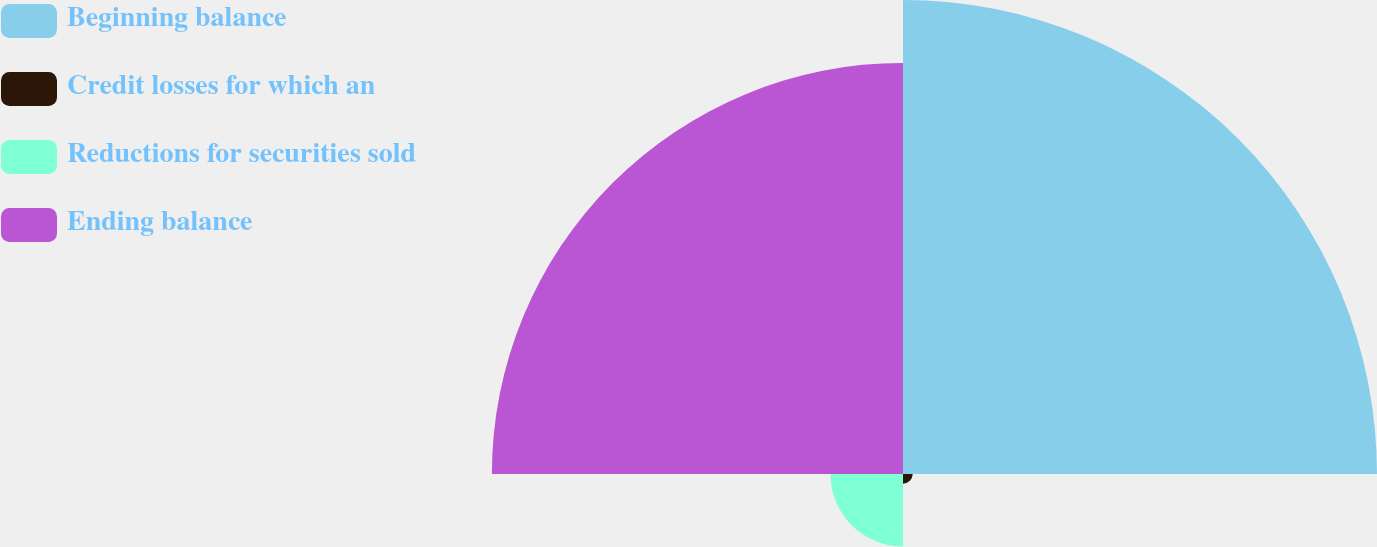<chart> <loc_0><loc_0><loc_500><loc_500><pie_chart><fcel>Beginning balance<fcel>Credit losses for which an<fcel>Reductions for securities sold<fcel>Ending balance<nl><fcel>49.0%<fcel>1.0%<fcel>7.5%<fcel>42.5%<nl></chart> 